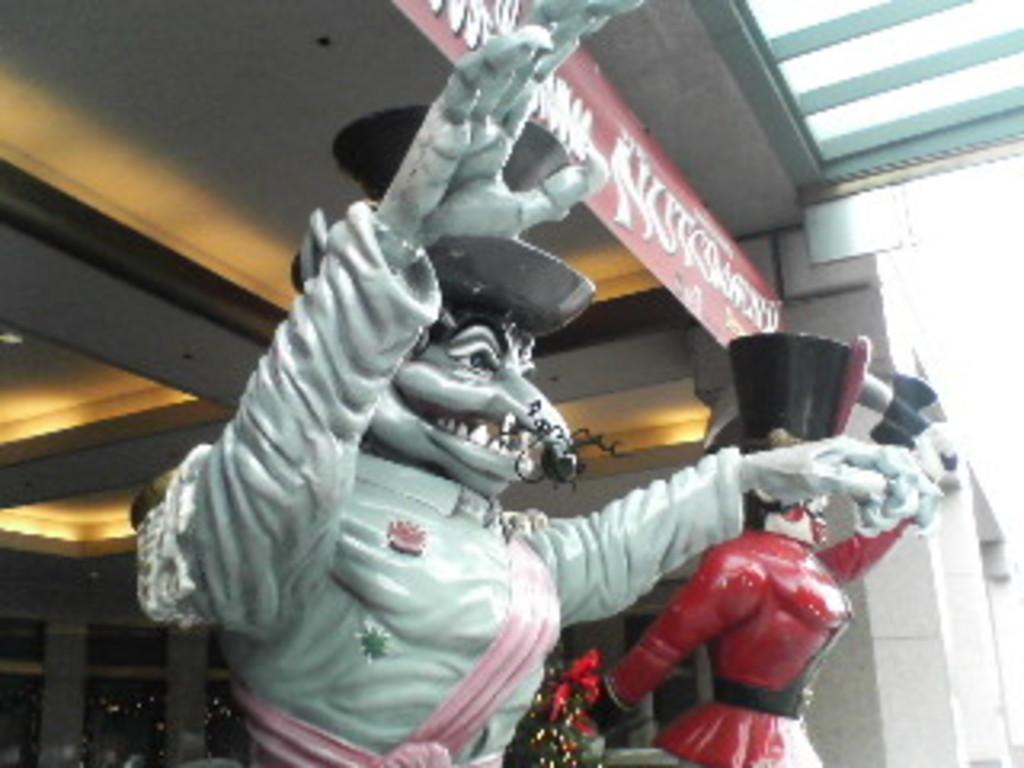What type of objects can be seen in the image? There are statues in the image. What seasonal decoration is present in the image? There is a decorated Christmas tree in the image. What type of signs or messages can be seen in the image? There are advertisements in the image. What type of lighting is visible in the image? Electric lights are visible in the image. What type of structure is present in the image? There is a building in the image. How many babies are visible in the image? There are no babies present in the image. What type of space-related objects can be seen in the image? There are no space-related objects present in the image. What type of clothing is visible on the statues in the image? The statues in the image do not have any clothing, as they are likely made of stone or another material. 